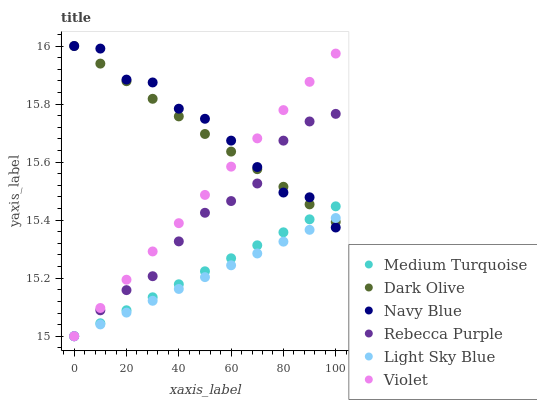Does Light Sky Blue have the minimum area under the curve?
Answer yes or no. Yes. Does Navy Blue have the maximum area under the curve?
Answer yes or no. Yes. Does Dark Olive have the minimum area under the curve?
Answer yes or no. No. Does Dark Olive have the maximum area under the curve?
Answer yes or no. No. Is Dark Olive the smoothest?
Answer yes or no. Yes. Is Navy Blue the roughest?
Answer yes or no. Yes. Is Light Sky Blue the smoothest?
Answer yes or no. No. Is Light Sky Blue the roughest?
Answer yes or no. No. Does Light Sky Blue have the lowest value?
Answer yes or no. Yes. Does Dark Olive have the lowest value?
Answer yes or no. No. Does Dark Olive have the highest value?
Answer yes or no. Yes. Does Light Sky Blue have the highest value?
Answer yes or no. No. Does Light Sky Blue intersect Violet?
Answer yes or no. Yes. Is Light Sky Blue less than Violet?
Answer yes or no. No. Is Light Sky Blue greater than Violet?
Answer yes or no. No. 